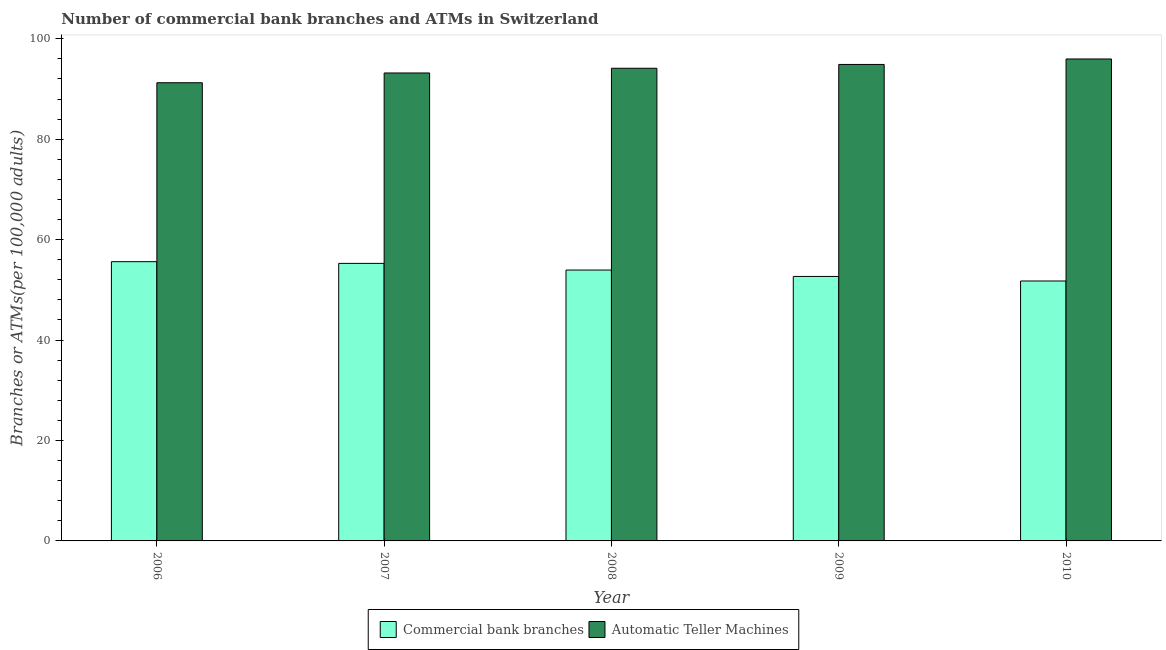How many different coloured bars are there?
Your response must be concise. 2. What is the label of the 5th group of bars from the left?
Provide a short and direct response. 2010. What is the number of atms in 2008?
Your answer should be very brief. 94.14. Across all years, what is the maximum number of commercal bank branches?
Make the answer very short. 55.62. Across all years, what is the minimum number of atms?
Make the answer very short. 91.25. In which year was the number of atms minimum?
Your answer should be very brief. 2006. What is the total number of atms in the graph?
Offer a very short reply. 469.46. What is the difference between the number of atms in 2006 and that in 2007?
Your answer should be compact. -1.94. What is the difference between the number of atms in 2009 and the number of commercal bank branches in 2007?
Your response must be concise. 1.7. What is the average number of commercal bank branches per year?
Your response must be concise. 53.85. In the year 2009, what is the difference between the number of commercal bank branches and number of atms?
Make the answer very short. 0. In how many years, is the number of atms greater than 32?
Your response must be concise. 5. What is the ratio of the number of commercal bank branches in 2008 to that in 2009?
Give a very brief answer. 1.02. Is the difference between the number of atms in 2008 and 2010 greater than the difference between the number of commercal bank branches in 2008 and 2010?
Your response must be concise. No. What is the difference between the highest and the second highest number of atms?
Keep it short and to the point. 1.09. What is the difference between the highest and the lowest number of commercal bank branches?
Your response must be concise. 3.85. In how many years, is the number of commercal bank branches greater than the average number of commercal bank branches taken over all years?
Your answer should be compact. 3. What does the 2nd bar from the left in 2006 represents?
Keep it short and to the point. Automatic Teller Machines. What does the 1st bar from the right in 2008 represents?
Make the answer very short. Automatic Teller Machines. Are all the bars in the graph horizontal?
Offer a very short reply. No. How many years are there in the graph?
Your response must be concise. 5. Are the values on the major ticks of Y-axis written in scientific E-notation?
Provide a succinct answer. No. Does the graph contain any zero values?
Your answer should be very brief. No. Does the graph contain grids?
Your response must be concise. No. Where does the legend appear in the graph?
Keep it short and to the point. Bottom center. How are the legend labels stacked?
Provide a succinct answer. Horizontal. What is the title of the graph?
Provide a short and direct response. Number of commercial bank branches and ATMs in Switzerland. What is the label or title of the Y-axis?
Offer a terse response. Branches or ATMs(per 100,0 adults). What is the Branches or ATMs(per 100,000 adults) of Commercial bank branches in 2006?
Ensure brevity in your answer.  55.62. What is the Branches or ATMs(per 100,000 adults) of Automatic Teller Machines in 2006?
Provide a short and direct response. 91.25. What is the Branches or ATMs(per 100,000 adults) in Commercial bank branches in 2007?
Give a very brief answer. 55.27. What is the Branches or ATMs(per 100,000 adults) of Automatic Teller Machines in 2007?
Offer a terse response. 93.2. What is the Branches or ATMs(per 100,000 adults) of Commercial bank branches in 2008?
Ensure brevity in your answer.  53.94. What is the Branches or ATMs(per 100,000 adults) of Automatic Teller Machines in 2008?
Ensure brevity in your answer.  94.14. What is the Branches or ATMs(per 100,000 adults) in Commercial bank branches in 2009?
Keep it short and to the point. 52.67. What is the Branches or ATMs(per 100,000 adults) in Automatic Teller Machines in 2009?
Your response must be concise. 94.89. What is the Branches or ATMs(per 100,000 adults) in Commercial bank branches in 2010?
Your response must be concise. 51.77. What is the Branches or ATMs(per 100,000 adults) of Automatic Teller Machines in 2010?
Make the answer very short. 95.98. Across all years, what is the maximum Branches or ATMs(per 100,000 adults) of Commercial bank branches?
Provide a short and direct response. 55.62. Across all years, what is the maximum Branches or ATMs(per 100,000 adults) of Automatic Teller Machines?
Your answer should be compact. 95.98. Across all years, what is the minimum Branches or ATMs(per 100,000 adults) of Commercial bank branches?
Your response must be concise. 51.77. Across all years, what is the minimum Branches or ATMs(per 100,000 adults) in Automatic Teller Machines?
Offer a terse response. 91.25. What is the total Branches or ATMs(per 100,000 adults) in Commercial bank branches in the graph?
Give a very brief answer. 269.27. What is the total Branches or ATMs(per 100,000 adults) of Automatic Teller Machines in the graph?
Make the answer very short. 469.46. What is the difference between the Branches or ATMs(per 100,000 adults) in Commercial bank branches in 2006 and that in 2007?
Ensure brevity in your answer.  0.34. What is the difference between the Branches or ATMs(per 100,000 adults) in Automatic Teller Machines in 2006 and that in 2007?
Your response must be concise. -1.94. What is the difference between the Branches or ATMs(per 100,000 adults) of Commercial bank branches in 2006 and that in 2008?
Your answer should be very brief. 1.67. What is the difference between the Branches or ATMs(per 100,000 adults) in Automatic Teller Machines in 2006 and that in 2008?
Offer a terse response. -2.88. What is the difference between the Branches or ATMs(per 100,000 adults) of Commercial bank branches in 2006 and that in 2009?
Your answer should be compact. 2.94. What is the difference between the Branches or ATMs(per 100,000 adults) of Automatic Teller Machines in 2006 and that in 2009?
Offer a very short reply. -3.64. What is the difference between the Branches or ATMs(per 100,000 adults) of Commercial bank branches in 2006 and that in 2010?
Keep it short and to the point. 3.85. What is the difference between the Branches or ATMs(per 100,000 adults) of Automatic Teller Machines in 2006 and that in 2010?
Your answer should be compact. -4.73. What is the difference between the Branches or ATMs(per 100,000 adults) in Commercial bank branches in 2007 and that in 2008?
Offer a terse response. 1.33. What is the difference between the Branches or ATMs(per 100,000 adults) in Automatic Teller Machines in 2007 and that in 2008?
Keep it short and to the point. -0.94. What is the difference between the Branches or ATMs(per 100,000 adults) in Commercial bank branches in 2007 and that in 2009?
Ensure brevity in your answer.  2.6. What is the difference between the Branches or ATMs(per 100,000 adults) of Automatic Teller Machines in 2007 and that in 2009?
Keep it short and to the point. -1.7. What is the difference between the Branches or ATMs(per 100,000 adults) of Commercial bank branches in 2007 and that in 2010?
Offer a very short reply. 3.5. What is the difference between the Branches or ATMs(per 100,000 adults) in Automatic Teller Machines in 2007 and that in 2010?
Provide a succinct answer. -2.79. What is the difference between the Branches or ATMs(per 100,000 adults) of Commercial bank branches in 2008 and that in 2009?
Your answer should be very brief. 1.27. What is the difference between the Branches or ATMs(per 100,000 adults) in Automatic Teller Machines in 2008 and that in 2009?
Your answer should be compact. -0.76. What is the difference between the Branches or ATMs(per 100,000 adults) of Commercial bank branches in 2008 and that in 2010?
Keep it short and to the point. 2.18. What is the difference between the Branches or ATMs(per 100,000 adults) in Automatic Teller Machines in 2008 and that in 2010?
Give a very brief answer. -1.85. What is the difference between the Branches or ATMs(per 100,000 adults) in Commercial bank branches in 2009 and that in 2010?
Offer a very short reply. 0.9. What is the difference between the Branches or ATMs(per 100,000 adults) in Automatic Teller Machines in 2009 and that in 2010?
Give a very brief answer. -1.09. What is the difference between the Branches or ATMs(per 100,000 adults) of Commercial bank branches in 2006 and the Branches or ATMs(per 100,000 adults) of Automatic Teller Machines in 2007?
Offer a very short reply. -37.58. What is the difference between the Branches or ATMs(per 100,000 adults) in Commercial bank branches in 2006 and the Branches or ATMs(per 100,000 adults) in Automatic Teller Machines in 2008?
Give a very brief answer. -38.52. What is the difference between the Branches or ATMs(per 100,000 adults) in Commercial bank branches in 2006 and the Branches or ATMs(per 100,000 adults) in Automatic Teller Machines in 2009?
Your answer should be very brief. -39.28. What is the difference between the Branches or ATMs(per 100,000 adults) in Commercial bank branches in 2006 and the Branches or ATMs(per 100,000 adults) in Automatic Teller Machines in 2010?
Your response must be concise. -40.37. What is the difference between the Branches or ATMs(per 100,000 adults) of Commercial bank branches in 2007 and the Branches or ATMs(per 100,000 adults) of Automatic Teller Machines in 2008?
Provide a short and direct response. -38.86. What is the difference between the Branches or ATMs(per 100,000 adults) of Commercial bank branches in 2007 and the Branches or ATMs(per 100,000 adults) of Automatic Teller Machines in 2009?
Offer a terse response. -39.62. What is the difference between the Branches or ATMs(per 100,000 adults) in Commercial bank branches in 2007 and the Branches or ATMs(per 100,000 adults) in Automatic Teller Machines in 2010?
Provide a succinct answer. -40.71. What is the difference between the Branches or ATMs(per 100,000 adults) of Commercial bank branches in 2008 and the Branches or ATMs(per 100,000 adults) of Automatic Teller Machines in 2009?
Offer a very short reply. -40.95. What is the difference between the Branches or ATMs(per 100,000 adults) in Commercial bank branches in 2008 and the Branches or ATMs(per 100,000 adults) in Automatic Teller Machines in 2010?
Give a very brief answer. -42.04. What is the difference between the Branches or ATMs(per 100,000 adults) of Commercial bank branches in 2009 and the Branches or ATMs(per 100,000 adults) of Automatic Teller Machines in 2010?
Offer a terse response. -43.31. What is the average Branches or ATMs(per 100,000 adults) in Commercial bank branches per year?
Offer a terse response. 53.85. What is the average Branches or ATMs(per 100,000 adults) of Automatic Teller Machines per year?
Keep it short and to the point. 93.89. In the year 2006, what is the difference between the Branches or ATMs(per 100,000 adults) in Commercial bank branches and Branches or ATMs(per 100,000 adults) in Automatic Teller Machines?
Offer a very short reply. -35.64. In the year 2007, what is the difference between the Branches or ATMs(per 100,000 adults) in Commercial bank branches and Branches or ATMs(per 100,000 adults) in Automatic Teller Machines?
Your answer should be very brief. -37.92. In the year 2008, what is the difference between the Branches or ATMs(per 100,000 adults) of Commercial bank branches and Branches or ATMs(per 100,000 adults) of Automatic Teller Machines?
Your answer should be compact. -40.19. In the year 2009, what is the difference between the Branches or ATMs(per 100,000 adults) in Commercial bank branches and Branches or ATMs(per 100,000 adults) in Automatic Teller Machines?
Offer a terse response. -42.22. In the year 2010, what is the difference between the Branches or ATMs(per 100,000 adults) in Commercial bank branches and Branches or ATMs(per 100,000 adults) in Automatic Teller Machines?
Make the answer very short. -44.22. What is the ratio of the Branches or ATMs(per 100,000 adults) of Automatic Teller Machines in 2006 to that in 2007?
Your response must be concise. 0.98. What is the ratio of the Branches or ATMs(per 100,000 adults) in Commercial bank branches in 2006 to that in 2008?
Keep it short and to the point. 1.03. What is the ratio of the Branches or ATMs(per 100,000 adults) in Automatic Teller Machines in 2006 to that in 2008?
Offer a very short reply. 0.97. What is the ratio of the Branches or ATMs(per 100,000 adults) in Commercial bank branches in 2006 to that in 2009?
Make the answer very short. 1.06. What is the ratio of the Branches or ATMs(per 100,000 adults) of Automatic Teller Machines in 2006 to that in 2009?
Keep it short and to the point. 0.96. What is the ratio of the Branches or ATMs(per 100,000 adults) of Commercial bank branches in 2006 to that in 2010?
Your answer should be very brief. 1.07. What is the ratio of the Branches or ATMs(per 100,000 adults) of Automatic Teller Machines in 2006 to that in 2010?
Your answer should be compact. 0.95. What is the ratio of the Branches or ATMs(per 100,000 adults) in Commercial bank branches in 2007 to that in 2008?
Keep it short and to the point. 1.02. What is the ratio of the Branches or ATMs(per 100,000 adults) of Commercial bank branches in 2007 to that in 2009?
Offer a terse response. 1.05. What is the ratio of the Branches or ATMs(per 100,000 adults) in Automatic Teller Machines in 2007 to that in 2009?
Your response must be concise. 0.98. What is the ratio of the Branches or ATMs(per 100,000 adults) in Commercial bank branches in 2007 to that in 2010?
Your answer should be very brief. 1.07. What is the ratio of the Branches or ATMs(per 100,000 adults) in Automatic Teller Machines in 2007 to that in 2010?
Provide a succinct answer. 0.97. What is the ratio of the Branches or ATMs(per 100,000 adults) of Commercial bank branches in 2008 to that in 2009?
Give a very brief answer. 1.02. What is the ratio of the Branches or ATMs(per 100,000 adults) of Automatic Teller Machines in 2008 to that in 2009?
Offer a terse response. 0.99. What is the ratio of the Branches or ATMs(per 100,000 adults) of Commercial bank branches in 2008 to that in 2010?
Your answer should be compact. 1.04. What is the ratio of the Branches or ATMs(per 100,000 adults) of Automatic Teller Machines in 2008 to that in 2010?
Keep it short and to the point. 0.98. What is the ratio of the Branches or ATMs(per 100,000 adults) of Commercial bank branches in 2009 to that in 2010?
Your answer should be very brief. 1.02. What is the ratio of the Branches or ATMs(per 100,000 adults) of Automatic Teller Machines in 2009 to that in 2010?
Your answer should be very brief. 0.99. What is the difference between the highest and the second highest Branches or ATMs(per 100,000 adults) in Commercial bank branches?
Provide a succinct answer. 0.34. What is the difference between the highest and the second highest Branches or ATMs(per 100,000 adults) of Automatic Teller Machines?
Give a very brief answer. 1.09. What is the difference between the highest and the lowest Branches or ATMs(per 100,000 adults) in Commercial bank branches?
Your response must be concise. 3.85. What is the difference between the highest and the lowest Branches or ATMs(per 100,000 adults) of Automatic Teller Machines?
Keep it short and to the point. 4.73. 